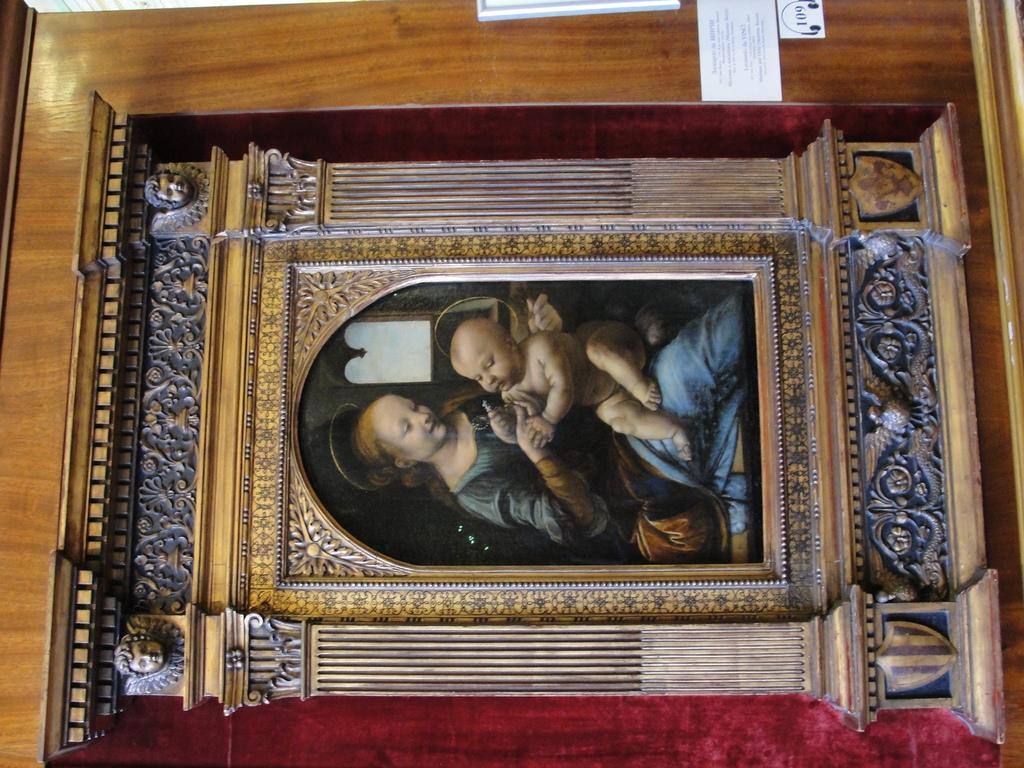What is on the wall in the image? There is a carved wooden frame on a wall. What is inside the wooden frame? The wooden frame contains a painting. What is the subject of the painting? The painting depicts a woman and a baby. What type of dinner is being served in the painting? There is no dinner depicted in the painting; it features a woman and a baby. 